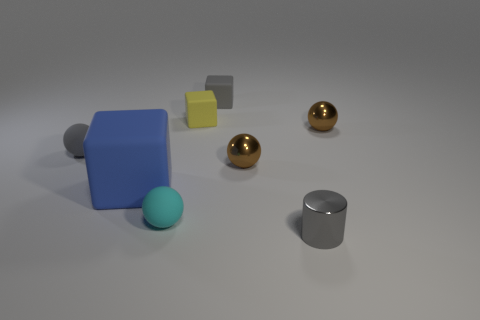Subtract all tiny rubber cubes. How many cubes are left? 1 Subtract all yellow cubes. How many cubes are left? 2 Subtract all cylinders. How many objects are left? 7 Add 2 tiny gray metal cylinders. How many objects exist? 10 Subtract 1 spheres. How many spheres are left? 3 Subtract all green cylinders. Subtract all gray cubes. How many cylinders are left? 1 Subtract 0 green blocks. How many objects are left? 8 Subtract all gray cylinders. How many yellow blocks are left? 1 Subtract all gray rubber blocks. Subtract all tiny cubes. How many objects are left? 5 Add 8 tiny metal cylinders. How many tiny metal cylinders are left? 9 